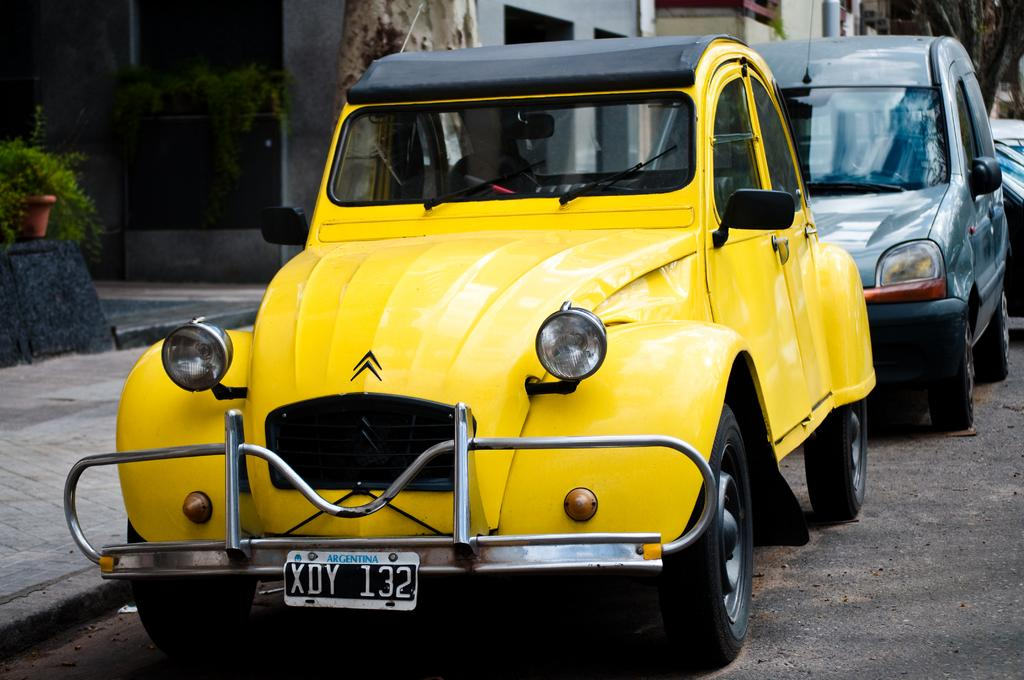<image>
Provide a brief description of the given image. a car with the numbers 132 on it 